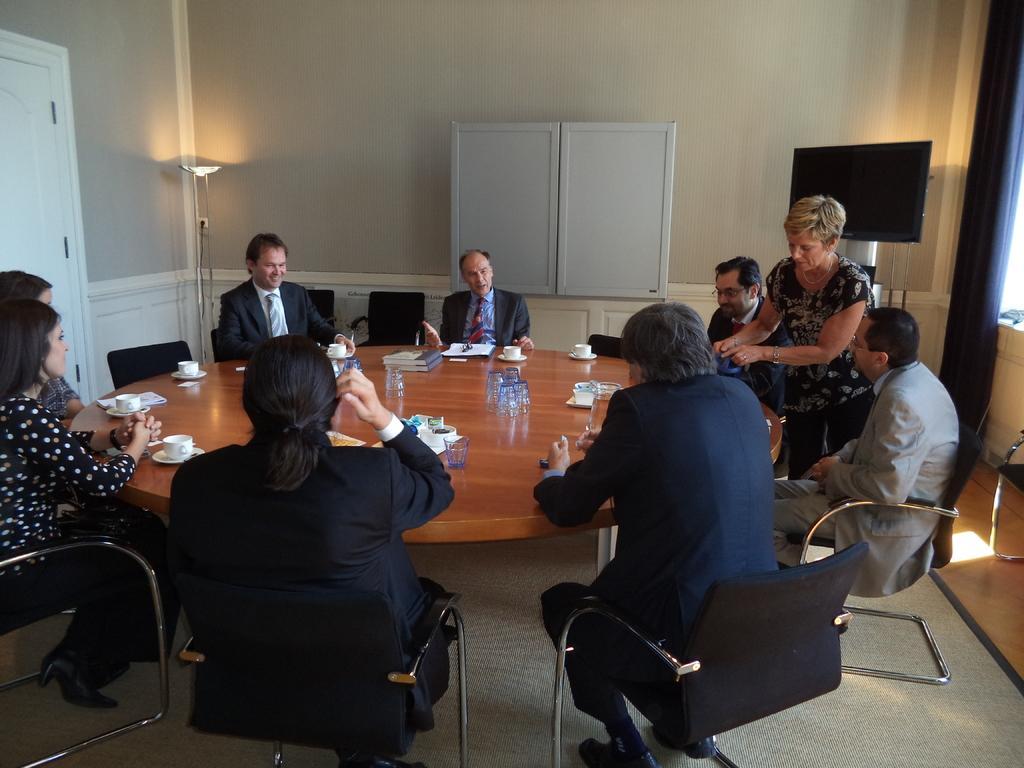In one or two sentences, can you explain what this image depicts? The photo is taken inside a meeting hall. There is a round table in the middle of the room. On the table there is books,glasses,bottle,cup,plate. Surrounding the table there are few chairs. On the chairs people are sitting. In the back in the middle one person is talking. On the right top corner there is a blue curtain. Beside it there is a screen. In the background there is a wall ,there is one cupboard. In the top left corner there is a light and a door beside it. On the floor there is a carpet. 